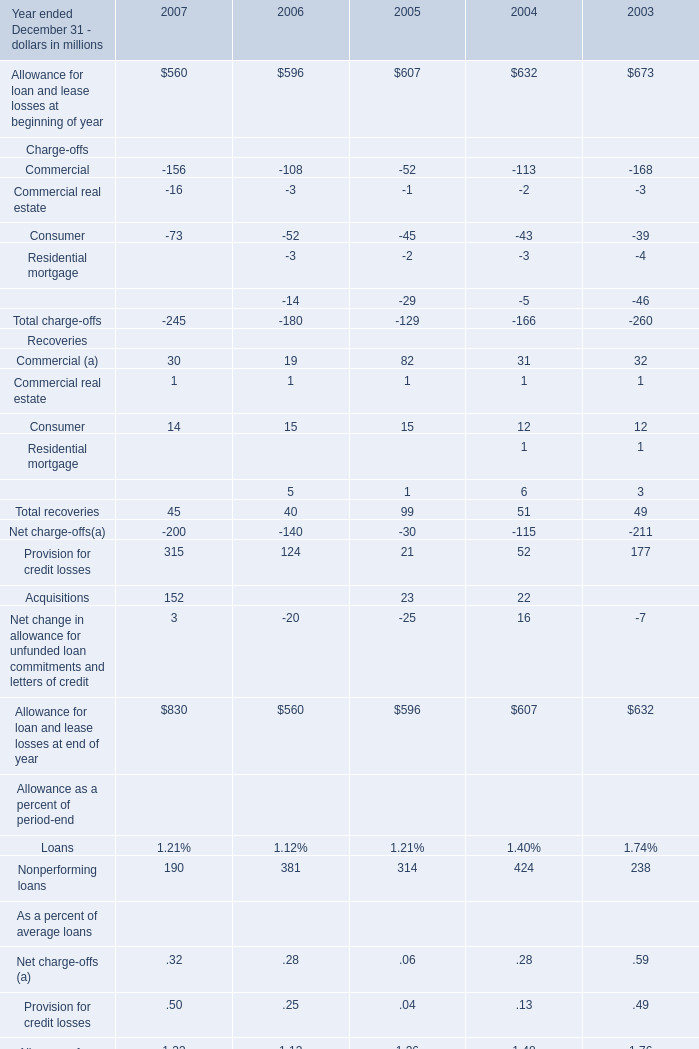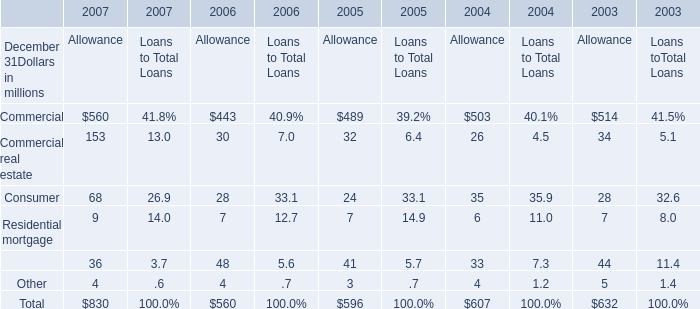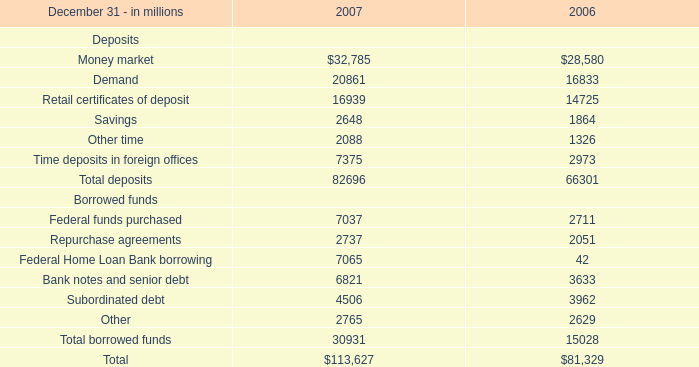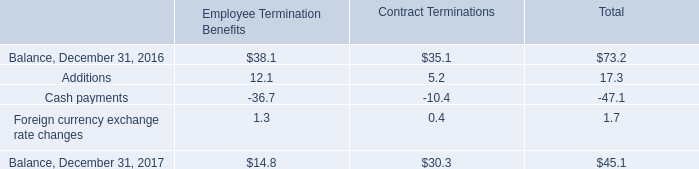If Nonperforming loans develops with the same growth rate in 2007, what will it reach in 2008? (in million) 
Computations: (190 * (1 + ((190 - 381) / 381)))
Answer: 94.75066. 